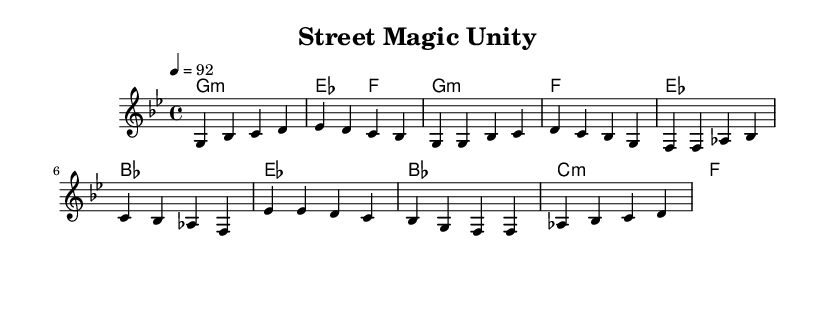What is the key signature of this music? The key signature is indicated at the beginning of the staff, showing two flats, which corresponds to G minor.
Answer: G minor What is the time signature of this music? The time signature is found at the beginning of the sheet music, represented by the fraction 4 over 4, meaning there are four beats in every measure and a quarter note gets one beat.
Answer: 4/4 What is the tempo marking for this piece? The tempo is indicated at the beginning of the score with "4 = 92," meaning there are 92 beats per minute, with the quarter note receiving one beat.
Answer: 92 How many measures are in the verse section? By counting the measures in the verse part of the melody, there are eight measures present.
Answer: 8 What is the first lyric of the chorus? The chorus starts with the words "Street Magic Unity,” which can be found at the beginning of the chorus lyrics right after the verse.
Answer: Street Magic Unity How does the harmony relate to the melody during the chorus? Analyzing the harmony during the chorus, the chords in the harmonies support the melody, creating a backdrop where the melody notes align with chord tones for the chant-like feel typical in hip hop, highlighting community themes.
Answer: They support the melody What is the primary theme expressed in the lyrics of this piece? The lyrics emphasize community, togetherness, and neighborhood pride, which aligns with common themes in hip hop that focus on local pride and unity.
Answer: Community building 